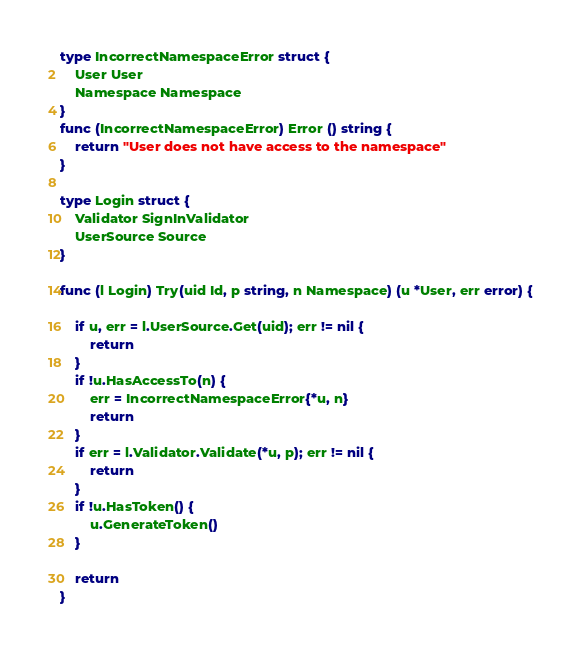Convert code to text. <code><loc_0><loc_0><loc_500><loc_500><_Go_>type IncorrectNamespaceError struct {
	User User
	Namespace Namespace
}
func (IncorrectNamespaceError) Error () string {
	return "User does not have access to the namespace"
}

type Login struct {
	Validator SignInValidator
	UserSource Source
}

func (l Login) Try(uid Id, p string, n Namespace) (u *User, err error) {

	if u, err = l.UserSource.Get(uid); err != nil {
		return
	}
	if !u.HasAccessTo(n) {
		err = IncorrectNamespaceError{*u, n}
		return
	}
	if err = l.Validator.Validate(*u, p); err != nil {
		return
	}
	if !u.HasToken() {
		u.GenerateToken()
	}

	return
}
</code> 